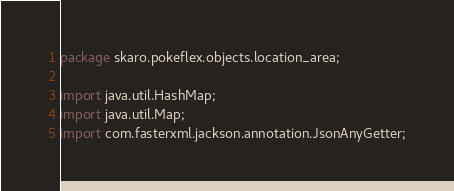<code> <loc_0><loc_0><loc_500><loc_500><_Java_>
package skaro.pokeflex.objects.location_area;

import java.util.HashMap;
import java.util.Map;
import com.fasterxml.jackson.annotation.JsonAnyGetter;</code> 